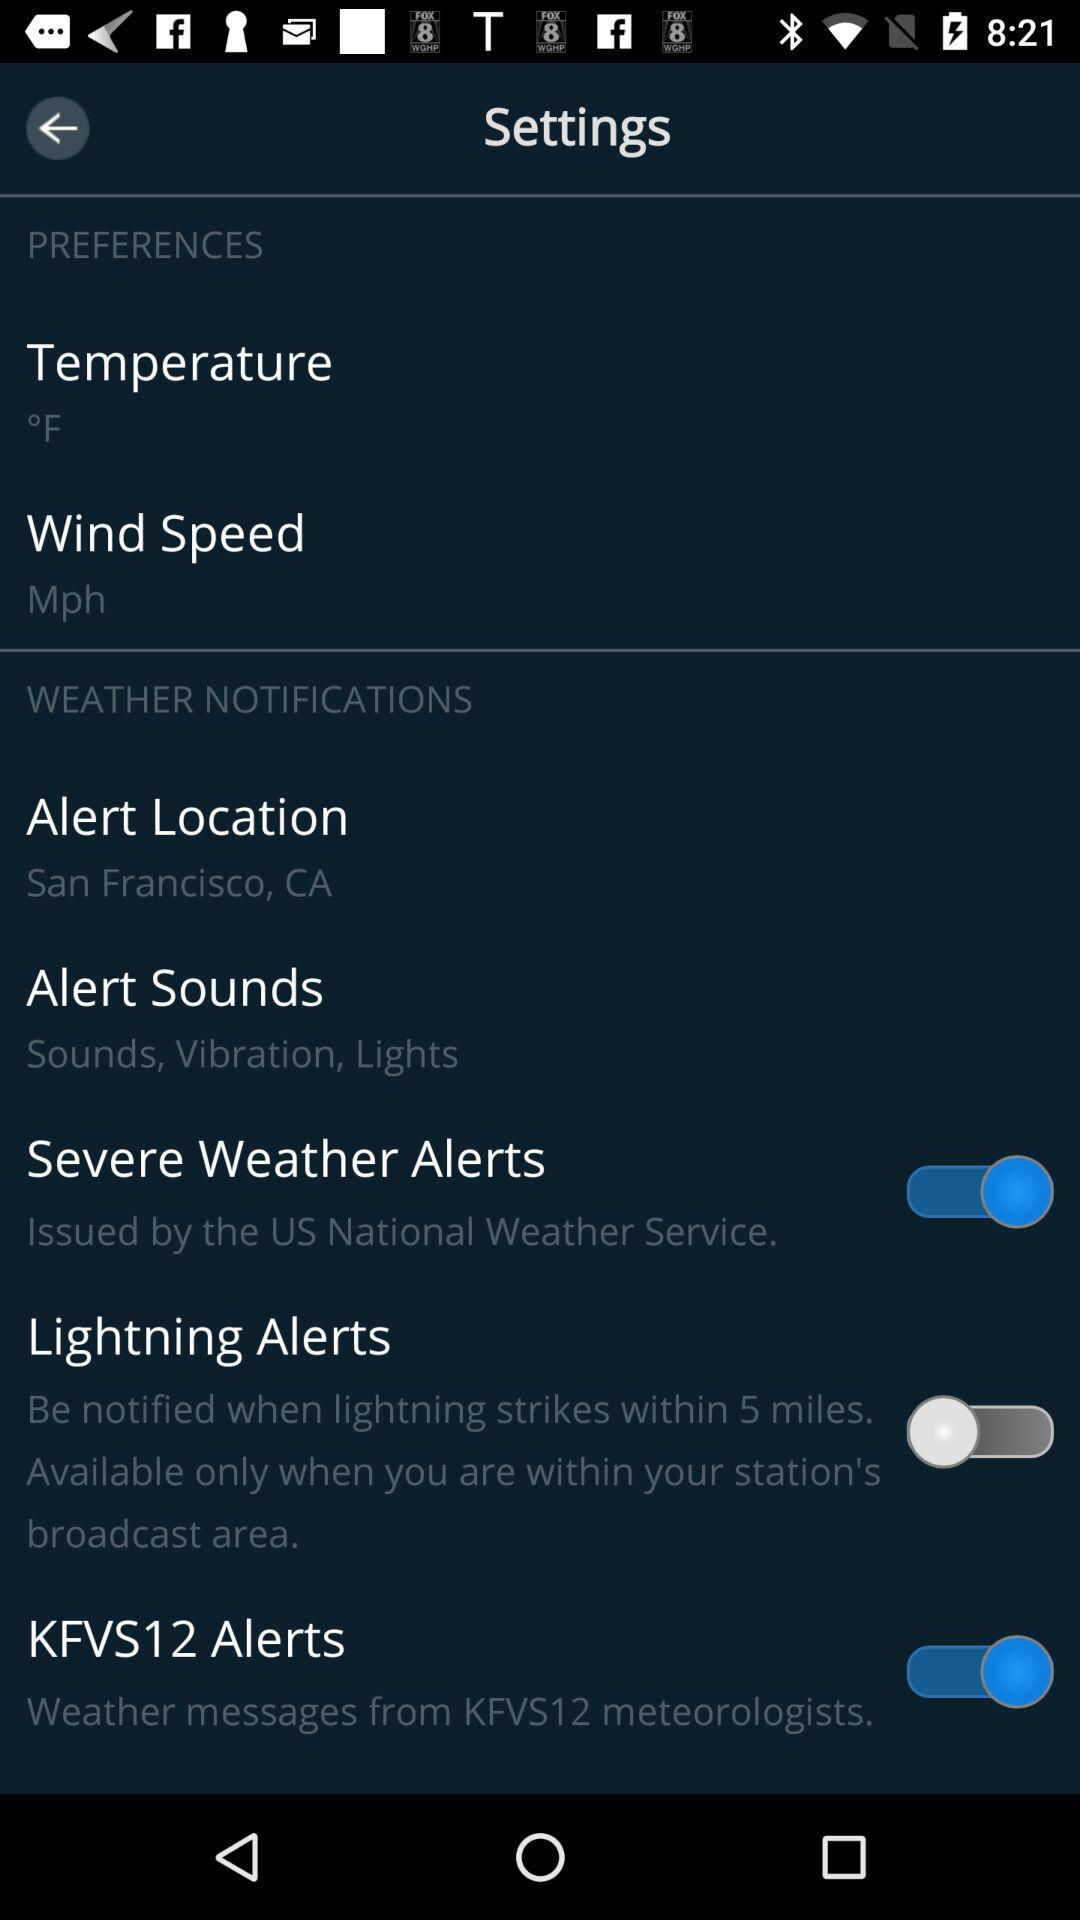What is the status of "Severe Weather Alerts"? The status is "on". 